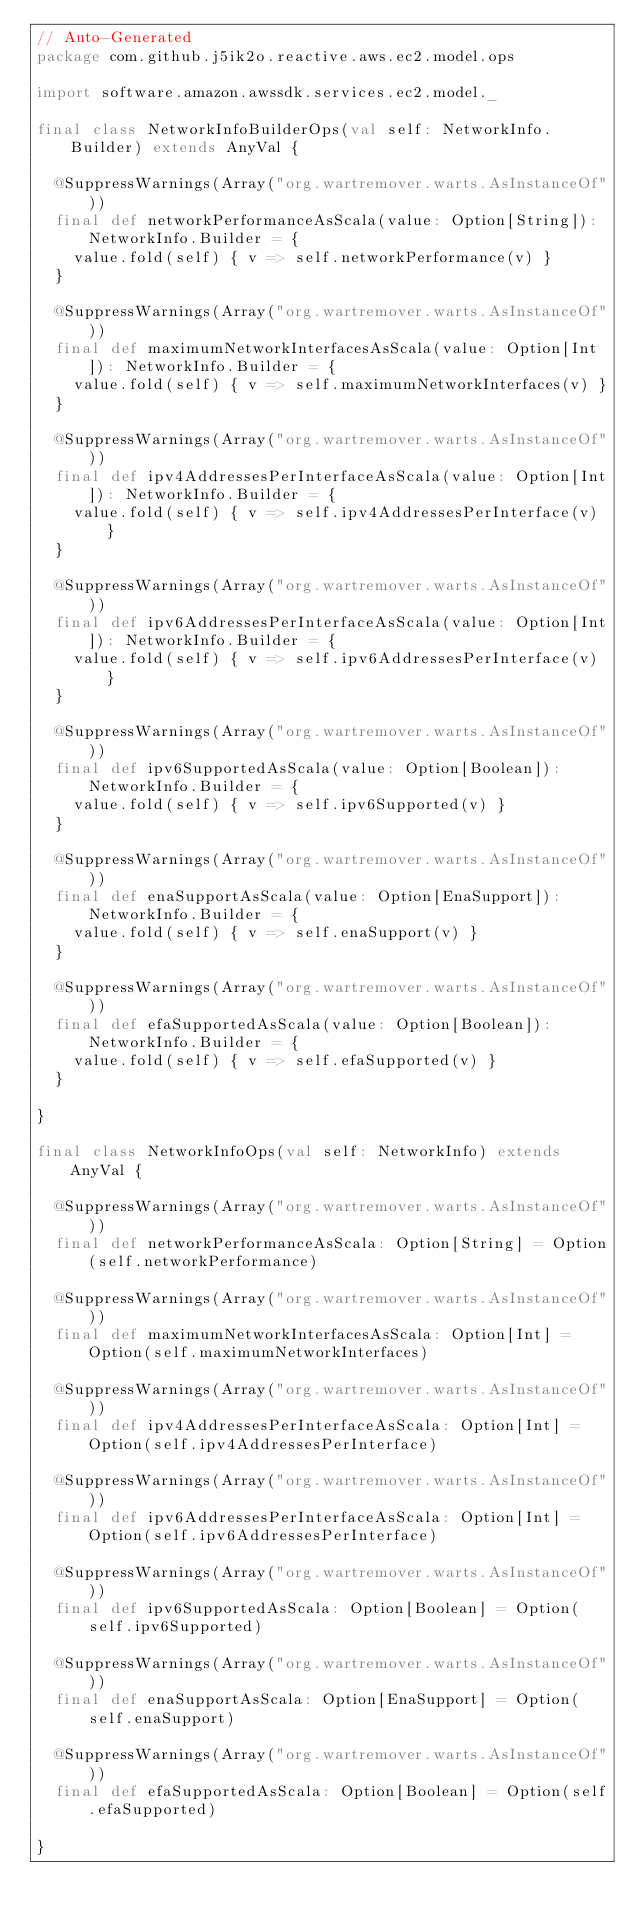<code> <loc_0><loc_0><loc_500><loc_500><_Scala_>// Auto-Generated
package com.github.j5ik2o.reactive.aws.ec2.model.ops

import software.amazon.awssdk.services.ec2.model._

final class NetworkInfoBuilderOps(val self: NetworkInfo.Builder) extends AnyVal {

  @SuppressWarnings(Array("org.wartremover.warts.AsInstanceOf"))
  final def networkPerformanceAsScala(value: Option[String]): NetworkInfo.Builder = {
    value.fold(self) { v => self.networkPerformance(v) }
  }

  @SuppressWarnings(Array("org.wartremover.warts.AsInstanceOf"))
  final def maximumNetworkInterfacesAsScala(value: Option[Int]): NetworkInfo.Builder = {
    value.fold(self) { v => self.maximumNetworkInterfaces(v) }
  }

  @SuppressWarnings(Array("org.wartremover.warts.AsInstanceOf"))
  final def ipv4AddressesPerInterfaceAsScala(value: Option[Int]): NetworkInfo.Builder = {
    value.fold(self) { v => self.ipv4AddressesPerInterface(v) }
  }

  @SuppressWarnings(Array("org.wartremover.warts.AsInstanceOf"))
  final def ipv6AddressesPerInterfaceAsScala(value: Option[Int]): NetworkInfo.Builder = {
    value.fold(self) { v => self.ipv6AddressesPerInterface(v) }
  }

  @SuppressWarnings(Array("org.wartremover.warts.AsInstanceOf"))
  final def ipv6SupportedAsScala(value: Option[Boolean]): NetworkInfo.Builder = {
    value.fold(self) { v => self.ipv6Supported(v) }
  }

  @SuppressWarnings(Array("org.wartremover.warts.AsInstanceOf"))
  final def enaSupportAsScala(value: Option[EnaSupport]): NetworkInfo.Builder = {
    value.fold(self) { v => self.enaSupport(v) }
  }

  @SuppressWarnings(Array("org.wartremover.warts.AsInstanceOf"))
  final def efaSupportedAsScala(value: Option[Boolean]): NetworkInfo.Builder = {
    value.fold(self) { v => self.efaSupported(v) }
  }

}

final class NetworkInfoOps(val self: NetworkInfo) extends AnyVal {

  @SuppressWarnings(Array("org.wartremover.warts.AsInstanceOf"))
  final def networkPerformanceAsScala: Option[String] = Option(self.networkPerformance)

  @SuppressWarnings(Array("org.wartremover.warts.AsInstanceOf"))
  final def maximumNetworkInterfacesAsScala: Option[Int] = Option(self.maximumNetworkInterfaces)

  @SuppressWarnings(Array("org.wartremover.warts.AsInstanceOf"))
  final def ipv4AddressesPerInterfaceAsScala: Option[Int] = Option(self.ipv4AddressesPerInterface)

  @SuppressWarnings(Array("org.wartremover.warts.AsInstanceOf"))
  final def ipv6AddressesPerInterfaceAsScala: Option[Int] = Option(self.ipv6AddressesPerInterface)

  @SuppressWarnings(Array("org.wartremover.warts.AsInstanceOf"))
  final def ipv6SupportedAsScala: Option[Boolean] = Option(self.ipv6Supported)

  @SuppressWarnings(Array("org.wartremover.warts.AsInstanceOf"))
  final def enaSupportAsScala: Option[EnaSupport] = Option(self.enaSupport)

  @SuppressWarnings(Array("org.wartremover.warts.AsInstanceOf"))
  final def efaSupportedAsScala: Option[Boolean] = Option(self.efaSupported)

}
</code> 